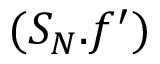Convert formula to latex. <formula><loc_0><loc_0><loc_500><loc_500>( S _ { N } . f ^ { \prime } )</formula> 